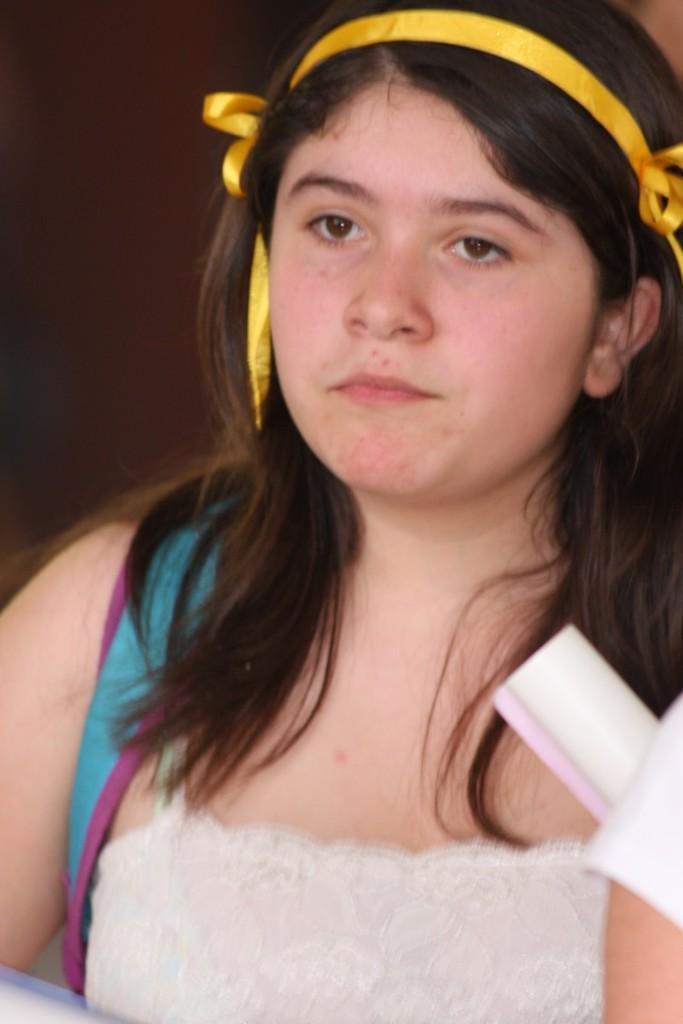How would you summarize this image in a sentence or two? This is a zoomed in picture. In the foreground there is a woman wearing a white color dress, backpack and the seems to be standing on the ground. On the right corner there is another person. 